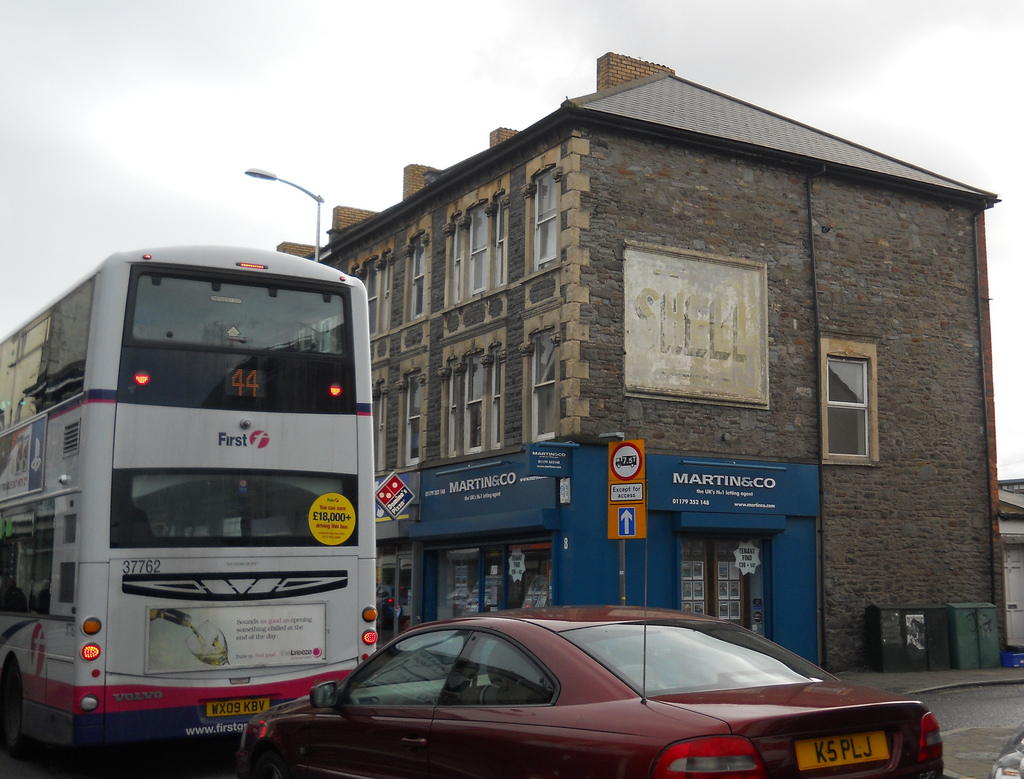Please provide the bounding box coordinate of the region this sentence describes: back window on car. The bounding box coordinate for the back window on the car is approximately [0.55, 0.71, 0.81, 0.79]. This identifies the region where the rear window of the car is situated, highlighting its exact position. 